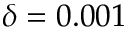Convert formula to latex. <formula><loc_0><loc_0><loc_500><loc_500>\delta = 0 . 0 0 1</formula> 